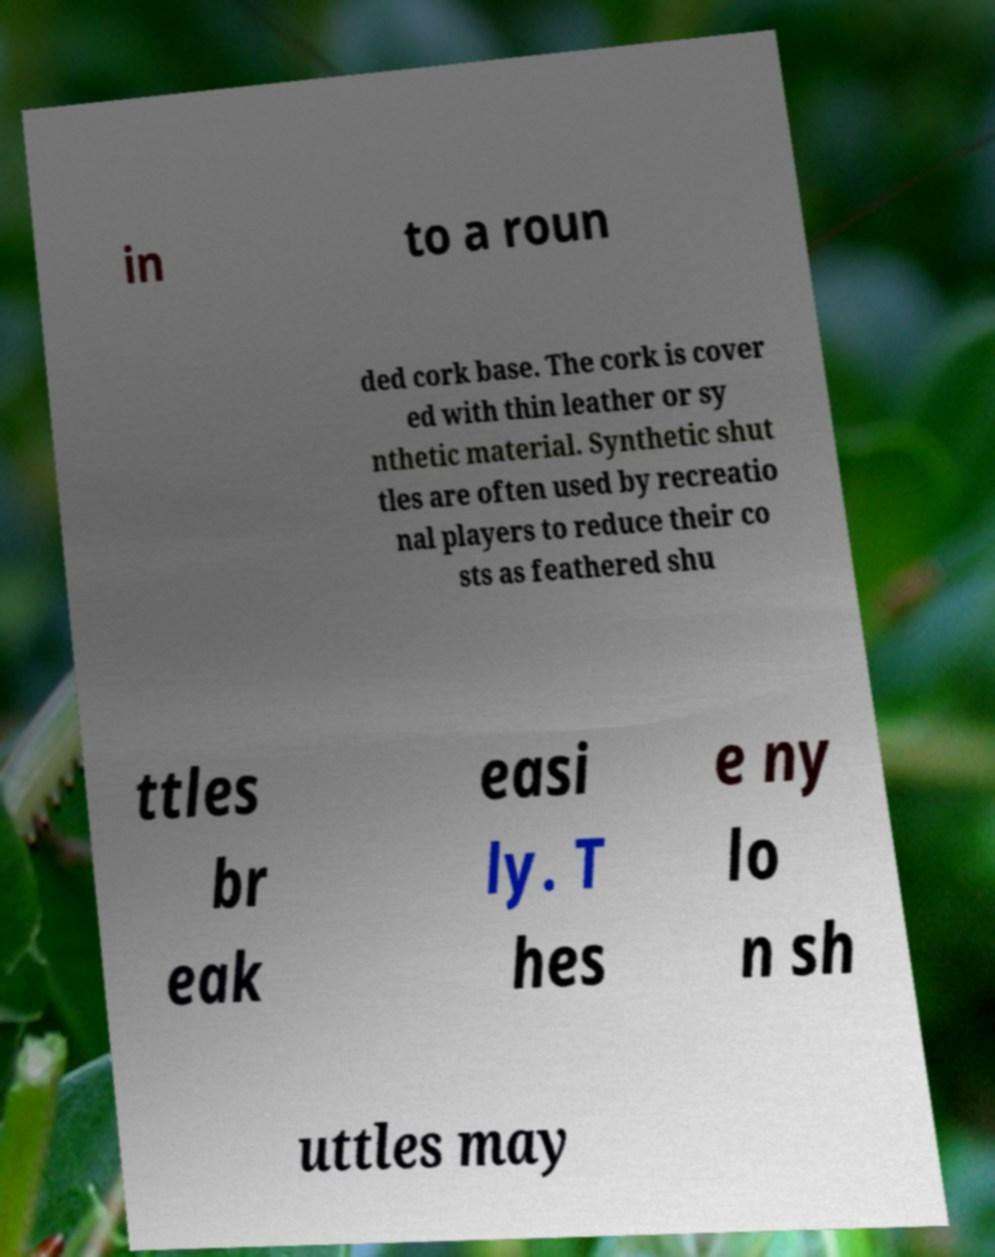What messages or text are displayed in this image? I need them in a readable, typed format. in to a roun ded cork base. The cork is cover ed with thin leather or sy nthetic material. Synthetic shut tles are often used by recreatio nal players to reduce their co sts as feathered shu ttles br eak easi ly. T hes e ny lo n sh uttles may 